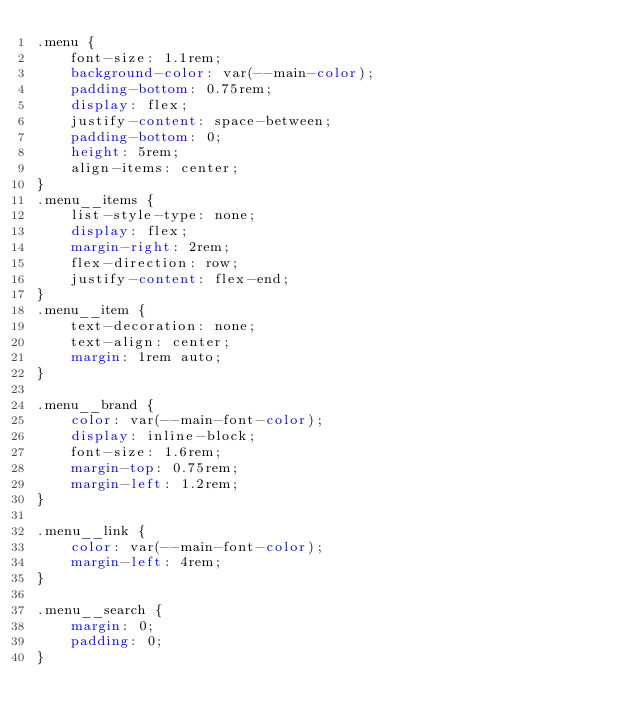<code> <loc_0><loc_0><loc_500><loc_500><_CSS_>.menu {
    font-size: 1.1rem;
    background-color: var(--main-color);
    padding-bottom: 0.75rem;
    display: flex;
    justify-content: space-between;
    padding-bottom: 0;
    height: 5rem;
    align-items: center;
}
.menu__items {
    list-style-type: none;
    display: flex;
    margin-right: 2rem;
    flex-direction: row;
    justify-content: flex-end;
}
.menu__item {
    text-decoration: none;
    text-align: center;
    margin: 1rem auto;
}

.menu__brand {
    color: var(--main-font-color);
    display: inline-block;
    font-size: 1.6rem;
    margin-top: 0.75rem;
    margin-left: 1.2rem;
}

.menu__link {
    color: var(--main-font-color);
    margin-left: 4rem;
}

.menu__search {
    margin: 0;
    padding: 0;
}</code> 